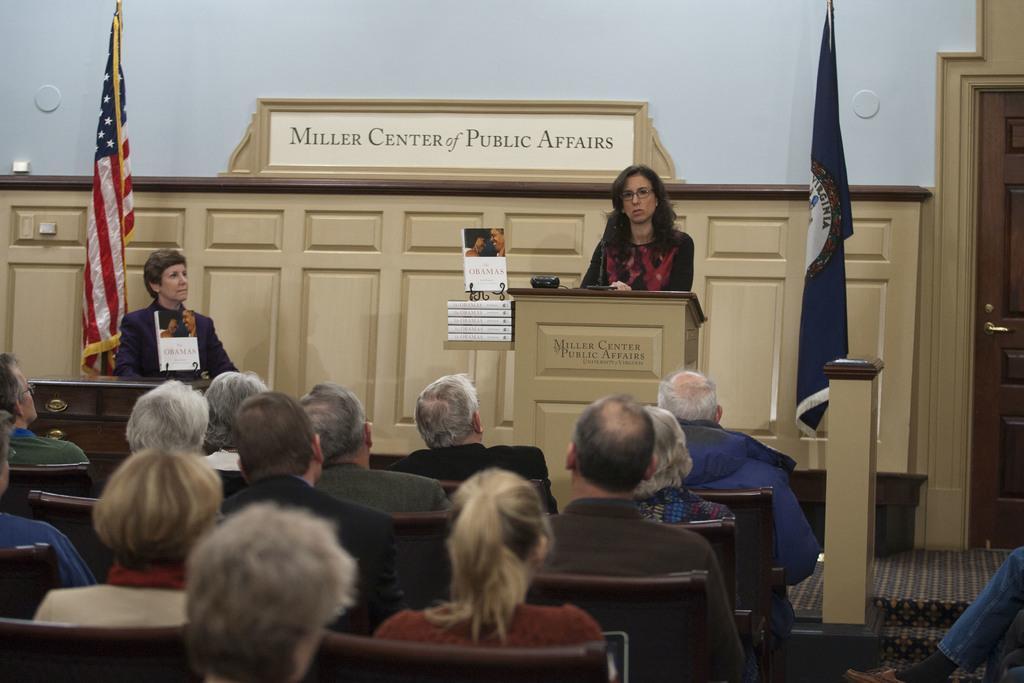Could you give a brief overview of what you see in this image? As we can see in the image there is a white color wall, flags, chairs, cupboards, door and group of people. 